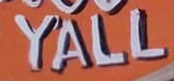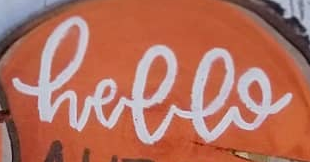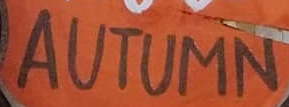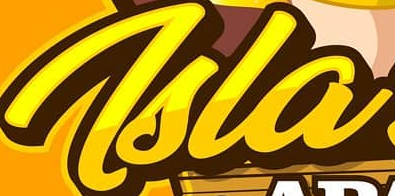Transcribe the words shown in these images in order, separated by a semicolon. YALL; hello; AUTUMN; Tsla 